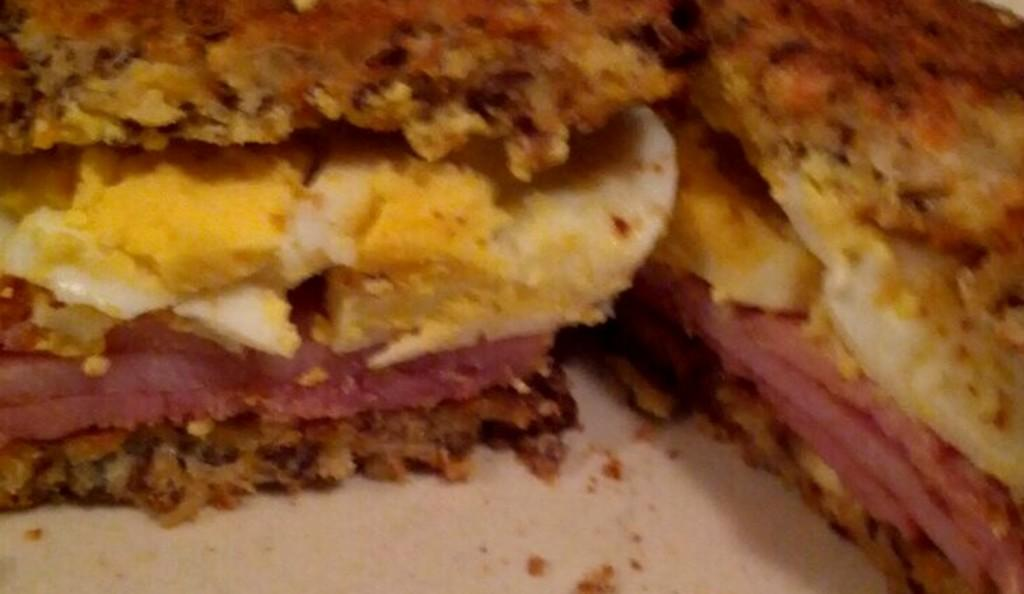What is on the plate in the image? There is food on a plate in the image. What type of food can be seen on the plate? The food contains meat and eggs. What happened to the can after the explosion in the image? There is no explosion or can present in the image; it only features food on a plate. 